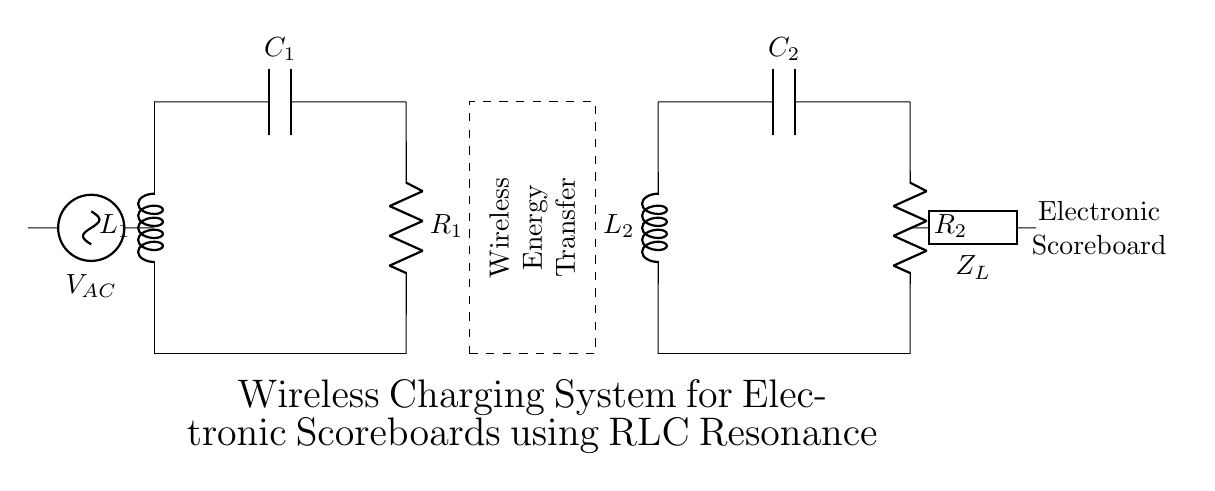What type of circuit is shown in the diagram? The circuit is an RLC circuit, consisting of resistors, inductors, and capacitors, indicated by the presence of R, L, and C components in the schematic.
Answer: RLC circuit What is the name of the main power supply? The main power supply is labeled as V_AC, indicating that it provides alternating current to the circuit.
Answer: V_AC How many inductors are present in the circuit? There are two inductors in the circuit, labeled L1 and L2, which are clearly shown in the diagram.
Answer: 2 What is the load connected to the RLC circuit? The load connected to the circuit is the electronic scoreboard, labeled as Z_L in the schematic, which utilizes the power supplied through the RLC resonance.
Answer: Electronic scoreboard What is the purpose of the dashed rectangle in the diagram? The dashed rectangle indicates the area for wireless energy transfer, suggesting that energy is being transmitted wirelessly to the receiver coil.
Answer: Wireless Energy Transfer How do the components L2, C2, and R2 relate to the load? L2, C2, and R2 form a resonant circuit that helps in transferring energy efficiently to the load (electronic scoreboard), facilitating wireless energy transfer and allowing for effective power delivery to the scoreboard.
Answer: They form a resonant circuit for energy transfer What does the label "C1" represent in the circuit? "C1" represents a capacitor in the circuit, which stores electrical energy and is part of the resonant circuit with L1, contributing to the circuit's overall functionality.
Answer: Capacitor 